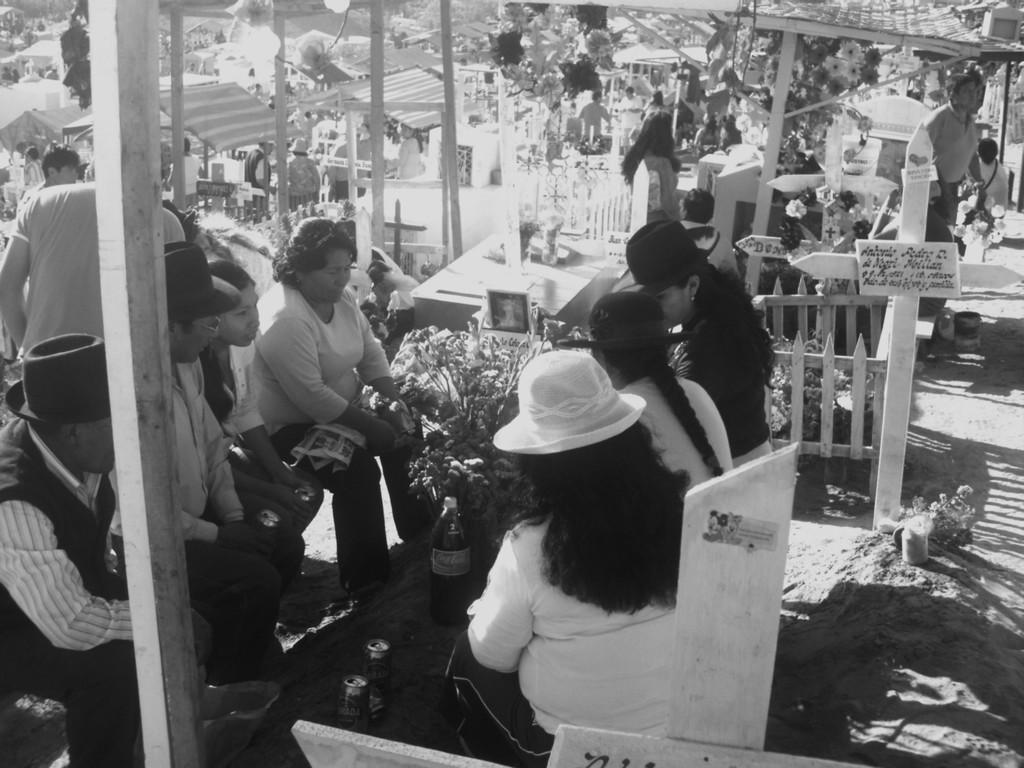How would you summarize this image in a sentence or two? This is a black and white image. In this image, we can see a group of people sitting on the chair in front of the table, at that table, we can see some coke tins and a bottle, plants. On the left side, we can see a pillar. On the right side, we can see a group of people, walking on the floor, wood grill and few boards, on that board, we can see few texts is written on it. In the background, we can see some pillars, plants, houses. 